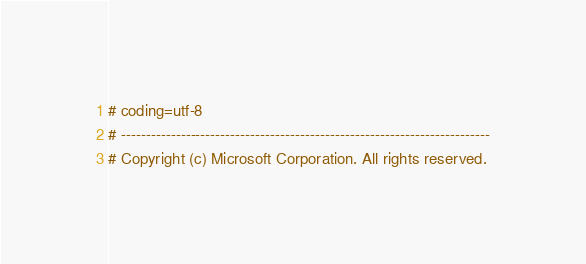Convert code to text. <code><loc_0><loc_0><loc_500><loc_500><_Python_># coding=utf-8
# --------------------------------------------------------------------------
# Copyright (c) Microsoft Corporation. All rights reserved.</code> 